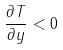Convert formula to latex. <formula><loc_0><loc_0><loc_500><loc_500>\frac { \partial T } { \partial y } < 0</formula> 